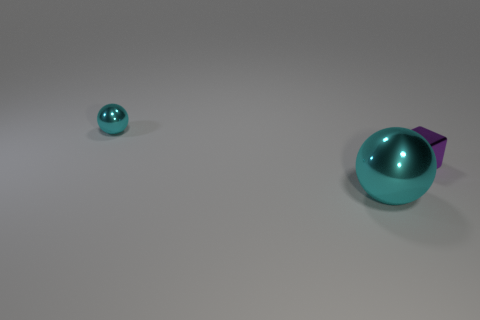Add 2 big gray blocks. How many objects exist? 5 Subtract all blocks. How many objects are left? 2 Subtract all blue spheres. Subtract all brown cubes. How many spheres are left? 2 Subtract all red cylinders. How many brown cubes are left? 0 Subtract all gray metallic cubes. Subtract all small blocks. How many objects are left? 2 Add 3 metallic objects. How many metallic objects are left? 6 Add 1 small red cylinders. How many small red cylinders exist? 1 Subtract 0 brown cylinders. How many objects are left? 3 